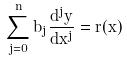<formula> <loc_0><loc_0><loc_500><loc_500>\sum _ { j = 0 } ^ { n } b _ { j } \frac { d ^ { j } y } { d x ^ { j } } = r ( x )</formula> 